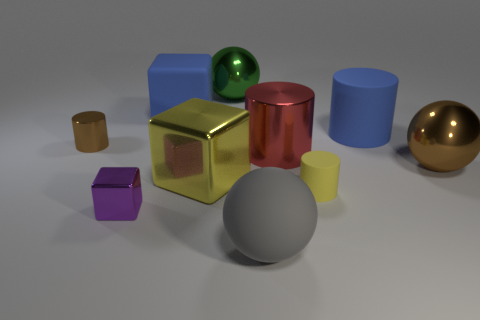Do the brown cylinder and the cube that is behind the tiny shiny cylinder have the same material?
Keep it short and to the point. No. Are there fewer yellow shiny cubes that are in front of the purple object than large red objects on the right side of the red metal object?
Give a very brief answer. No. What number of purple rubber cubes are there?
Your answer should be compact. 0. Is there anything else that is made of the same material as the tiny yellow thing?
Keep it short and to the point. Yes. What material is the gray thing that is the same shape as the big brown shiny thing?
Your response must be concise. Rubber. Are there fewer large green metallic spheres to the right of the purple shiny object than brown metal cylinders?
Your answer should be very brief. No. There is a tiny metallic object behind the red shiny cylinder; does it have the same shape as the red metallic thing?
Your response must be concise. Yes. Is there any other thing that is the same color as the small matte thing?
Your answer should be very brief. Yes. What size is the purple object that is made of the same material as the brown cylinder?
Offer a terse response. Small. What is the material of the sphere in front of the block left of the blue matte thing on the left side of the tiny yellow matte thing?
Ensure brevity in your answer.  Rubber. 